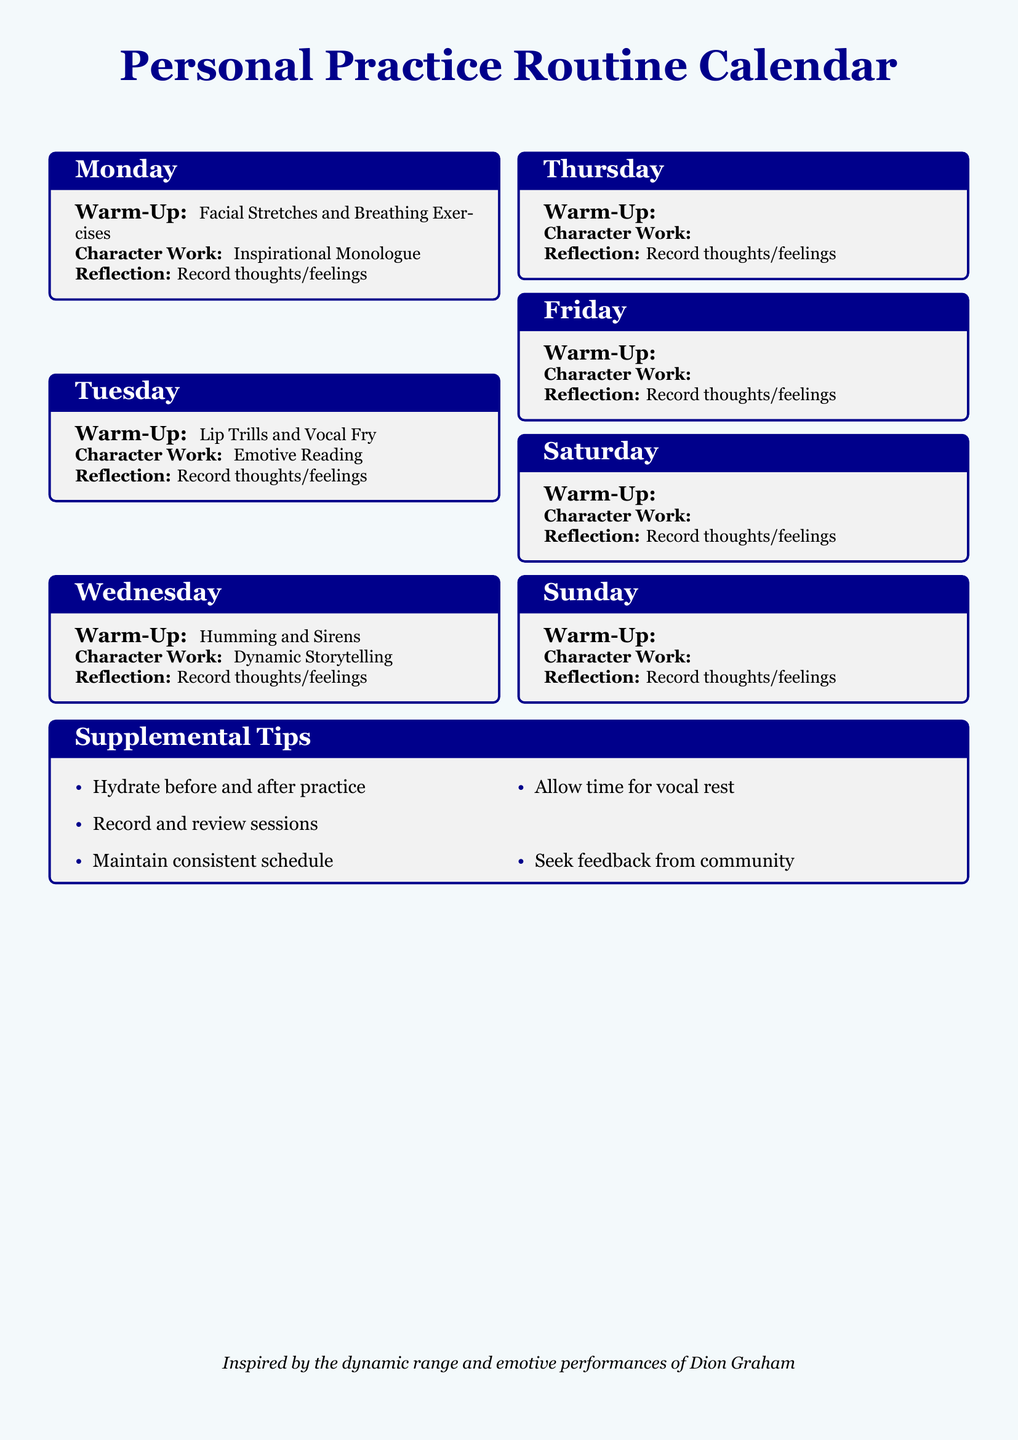What warm-up is listed for Monday? The warm-up for Monday is specifically stated in the document as Facial Stretches and Breathing Exercises.
Answer: Facial Stretches and Breathing Exercises What type of character work is scheduled for Thursday? The character work for Thursday is outlined as Dialogue Practice.
Answer: Dialogue Practice How many days of the week are included in the calendar? The calendar includes practice routines for each day of the week, which is a total of 7 days.
Answer: 7 What is one of the supplemental tips included in the document? One of the supplemental tips is to hydrate before and after practice, which is explicitly mentioned in the tips section.
Answer: Hydrate before and after practice Which warm-up involves lip trills? The warm-up involving lip trills is designated for Tuesday, as stated in the warm-up section for that day.
Answer: Lip Trills and Vocal Fry How many types of character work are mentioned in the calendar? There are 7 types of character work mentioned, one for each day of the week in the document.
Answer: 7 What is the purpose of the reflection section? The reflection section instructs to record thoughts or feelings, as mentioned in each day's practice routine.
Answer: Record thoughts/feelings What is a recommended action to maintain vocal health? A recommended action to maintain vocal health listed in the supplemental tips is to allow time for vocal rest.
Answer: Allow time for vocal rest 